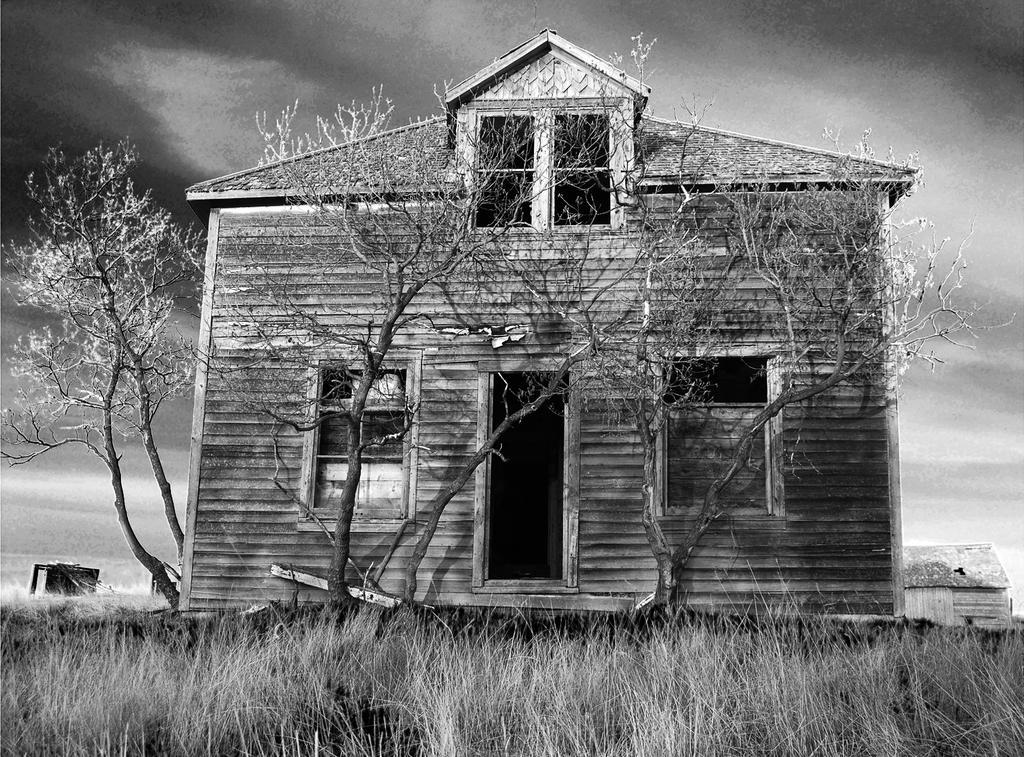Please provide a concise description of this image. In this picture I can see grass in the foreground. I can see house in the middle. I can see trees. 